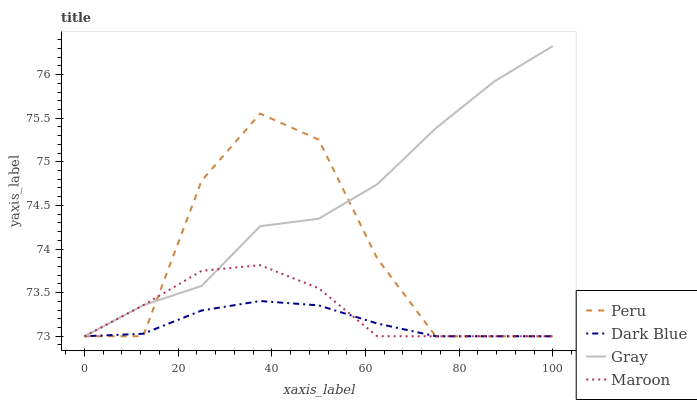Does Dark Blue have the minimum area under the curve?
Answer yes or no. Yes. Does Gray have the maximum area under the curve?
Answer yes or no. Yes. Does Maroon have the minimum area under the curve?
Answer yes or no. No. Does Maroon have the maximum area under the curve?
Answer yes or no. No. Is Dark Blue the smoothest?
Answer yes or no. Yes. Is Peru the roughest?
Answer yes or no. Yes. Is Maroon the smoothest?
Answer yes or no. No. Is Maroon the roughest?
Answer yes or no. No. Does Gray have the highest value?
Answer yes or no. Yes. Does Maroon have the highest value?
Answer yes or no. No. Does Dark Blue intersect Peru?
Answer yes or no. Yes. Is Dark Blue less than Peru?
Answer yes or no. No. Is Dark Blue greater than Peru?
Answer yes or no. No. 